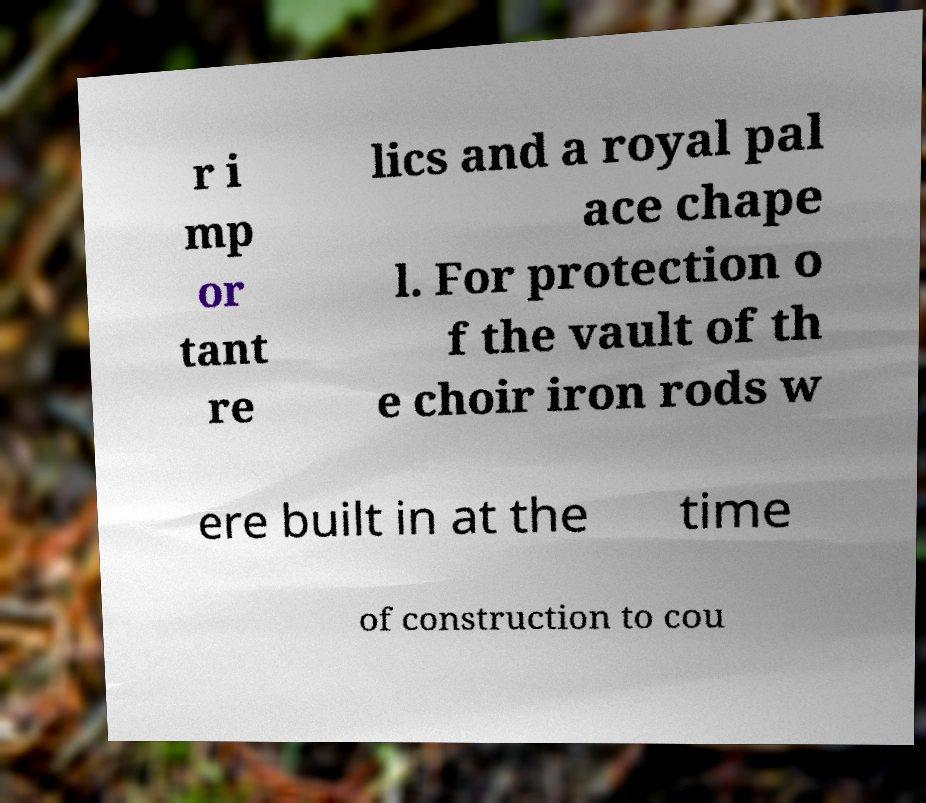Please identify and transcribe the text found in this image. r i mp or tant re lics and a royal pal ace chape l. For protection o f the vault of th e choir iron rods w ere built in at the time of construction to cou 